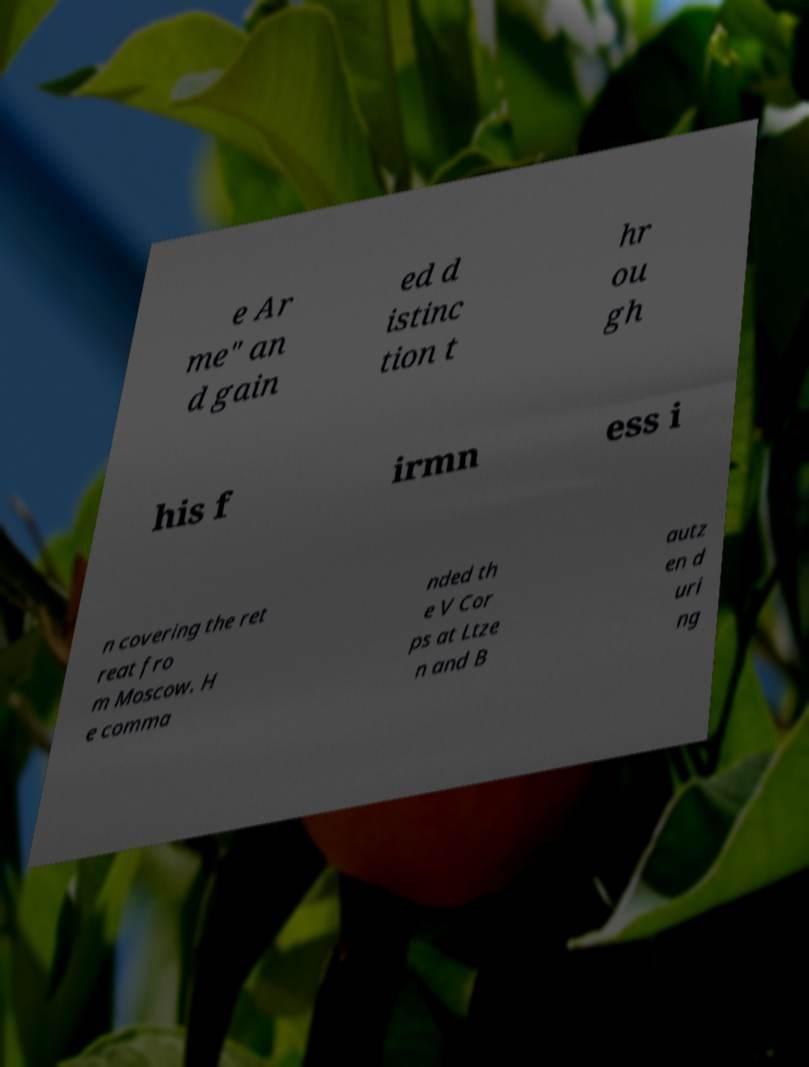What messages or text are displayed in this image? I need them in a readable, typed format. e Ar me" an d gain ed d istinc tion t hr ou gh his f irmn ess i n covering the ret reat fro m Moscow. H e comma nded th e V Cor ps at Ltze n and B autz en d uri ng 